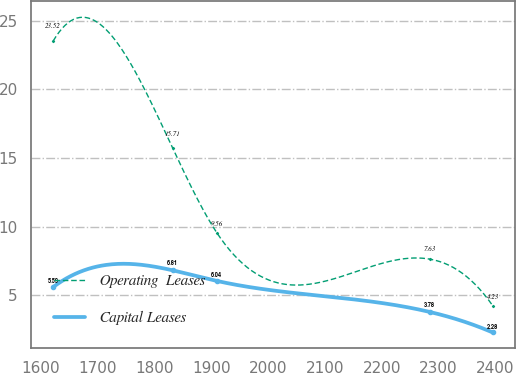<chart> <loc_0><loc_0><loc_500><loc_500><line_chart><ecel><fcel>Operating  Leases<fcel>Capital Leases<nl><fcel>1621.83<fcel>23.52<fcel>5.59<nl><fcel>1832.33<fcel>15.71<fcel>6.81<nl><fcel>1909.69<fcel>9.56<fcel>6.04<nl><fcel>2284.25<fcel>7.63<fcel>3.78<nl><fcel>2395.4<fcel>4.23<fcel>2.28<nl></chart> 